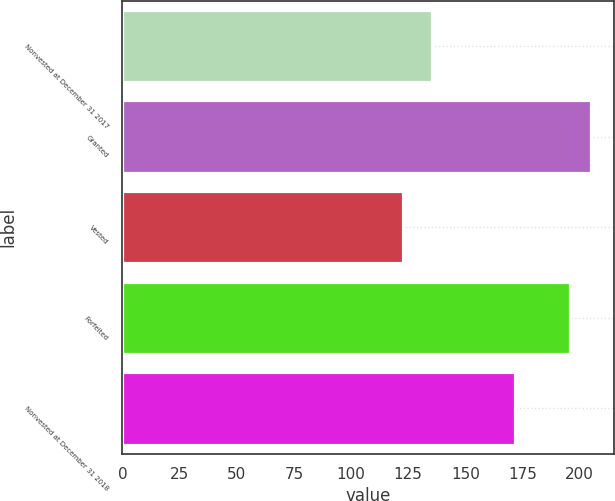<chart> <loc_0><loc_0><loc_500><loc_500><bar_chart><fcel>Nonvested at December 31 2017<fcel>Granted<fcel>Vested<fcel>Forfeited<fcel>Nonvested at December 31 2018<nl><fcel>135.38<fcel>204.97<fcel>122.59<fcel>195.99<fcel>171.62<nl></chart> 